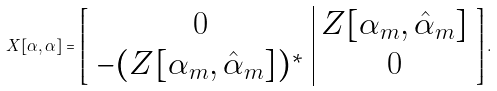Convert formula to latex. <formula><loc_0><loc_0><loc_500><loc_500>X [ \alpha , \alpha ] = \left [ \begin{array} { c | c } 0 & Z [ \alpha _ { m } , \hat { \alpha } _ { m } ] \\ - ( Z [ \alpha _ { m } , \hat { \alpha } _ { m } ] ) ^ { * } & 0 \end{array} \right ] .</formula> 